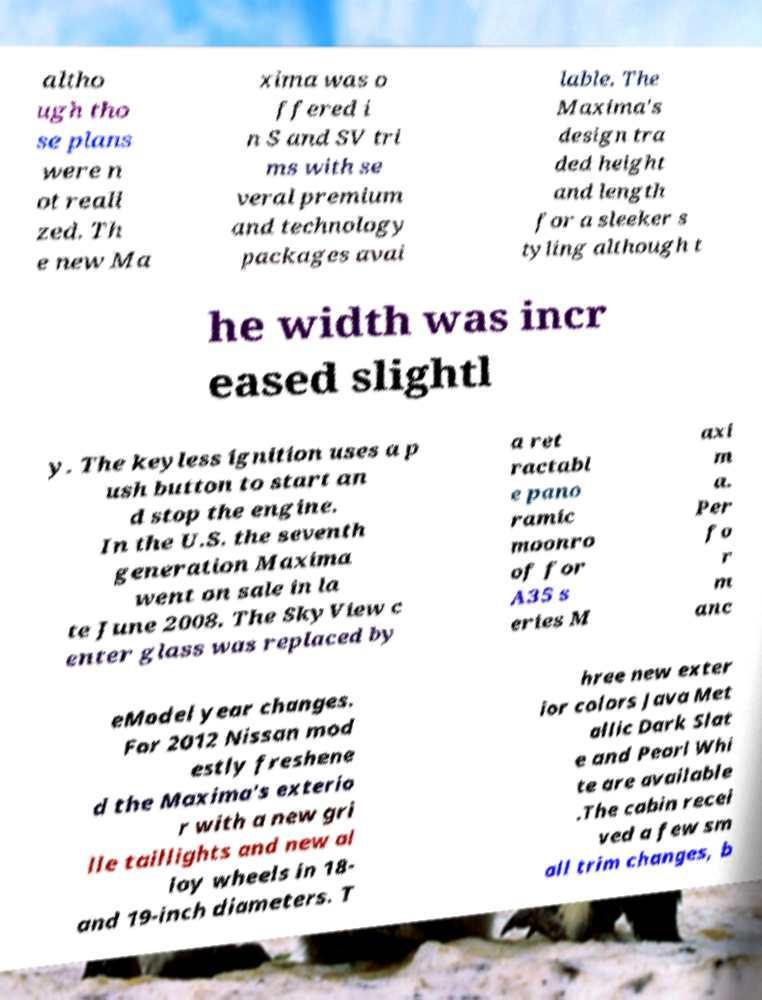What messages or text are displayed in this image? I need them in a readable, typed format. altho ugh tho se plans were n ot reali zed. Th e new Ma xima was o ffered i n S and SV tri ms with se veral premium and technology packages avai lable. The Maxima's design tra ded height and length for a sleeker s tyling although t he width was incr eased slightl y. The keyless ignition uses a p ush button to start an d stop the engine. In the U.S. the seventh generation Maxima went on sale in la te June 2008. The SkyView c enter glass was replaced by a ret ractabl e pano ramic moonro of for A35 s eries M axi m a. Per fo r m anc eModel year changes. For 2012 Nissan mod estly freshene d the Maxima's exterio r with a new gri lle taillights and new al loy wheels in 18- and 19-inch diameters. T hree new exter ior colors Java Met allic Dark Slat e and Pearl Whi te are available .The cabin recei ved a few sm all trim changes, b 